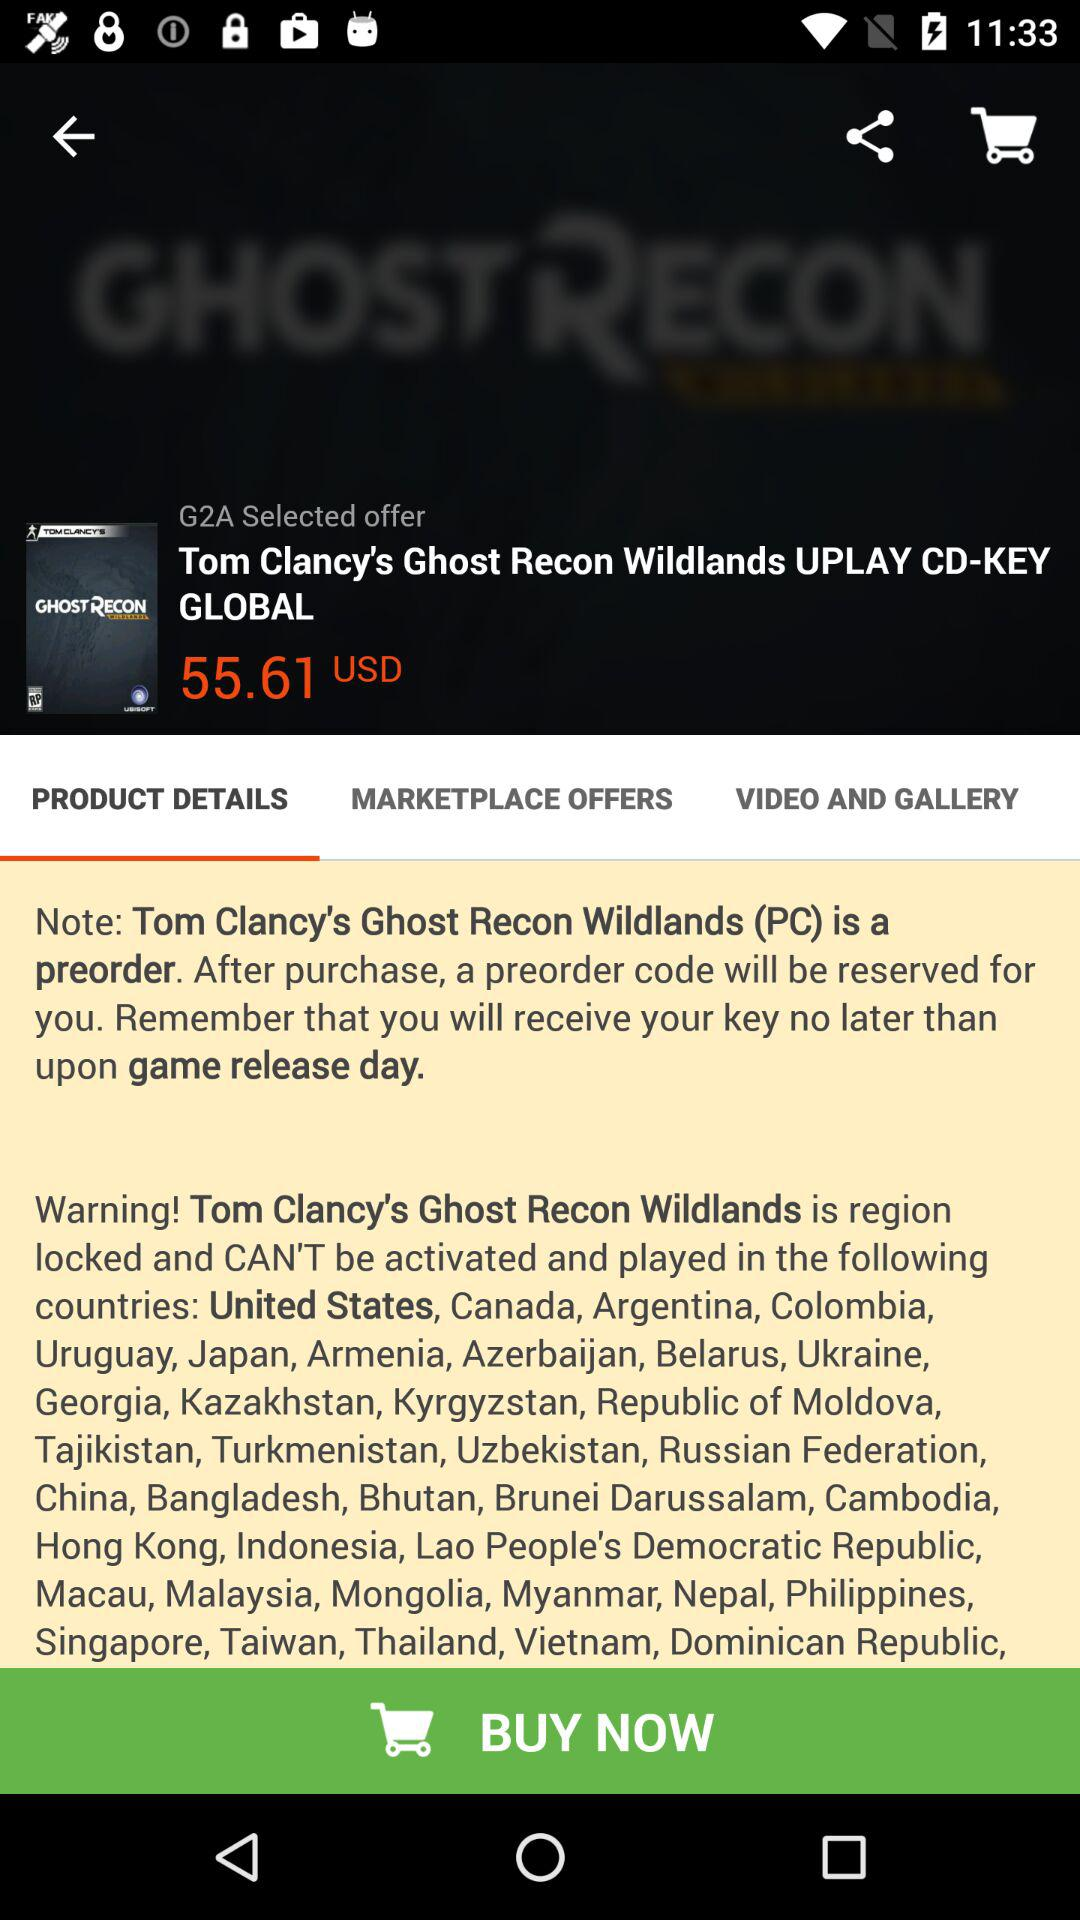What is the cost? The cost is 55.61 USD. 